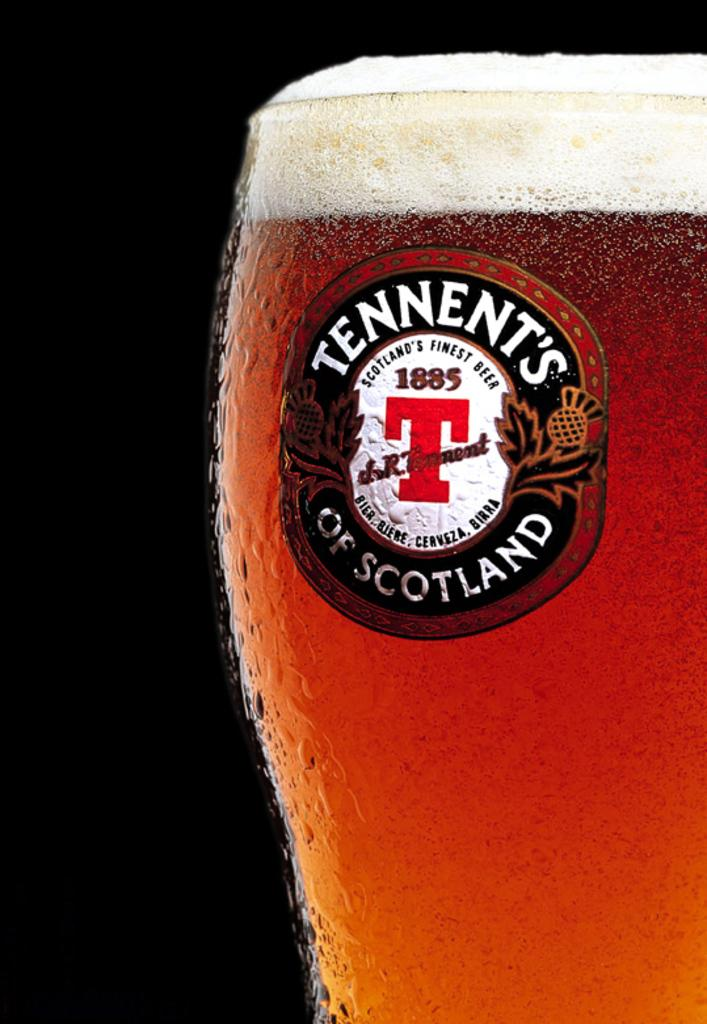<image>
Offer a succinct explanation of the picture presented. A glass of beer with foam on the top that says Tennent's of Scotland Scotland's Finest Beer 1885 with a large T on the middle of the glass. 